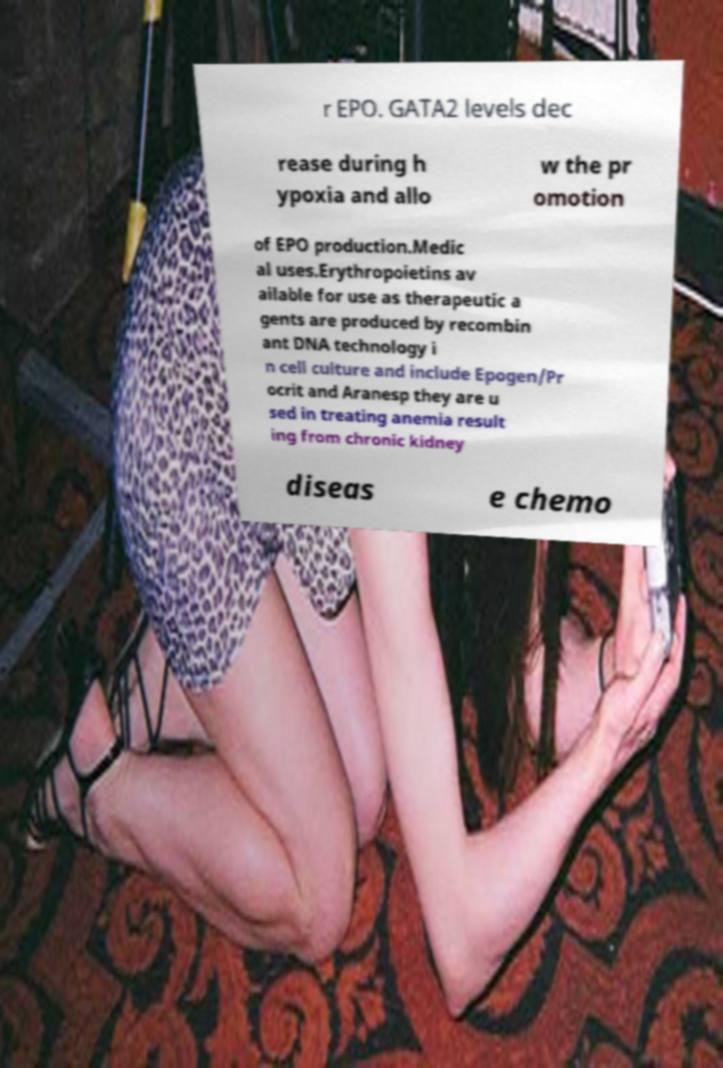Can you accurately transcribe the text from the provided image for me? r EPO. GATA2 levels dec rease during h ypoxia and allo w the pr omotion of EPO production.Medic al uses.Erythropoietins av ailable for use as therapeutic a gents are produced by recombin ant DNA technology i n cell culture and include Epogen/Pr ocrit and Aranesp they are u sed in treating anemia result ing from chronic kidney diseas e chemo 